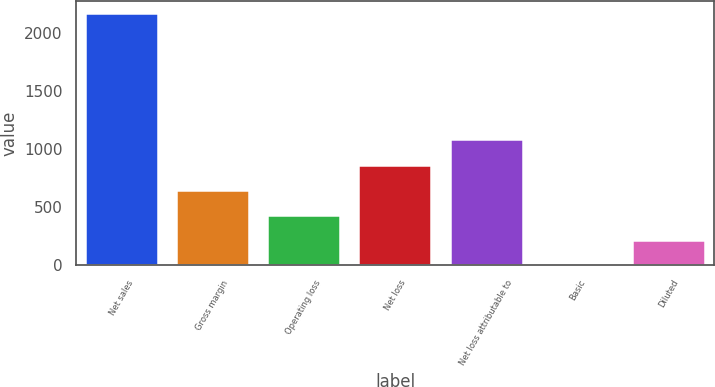Convert chart to OTSL. <chart><loc_0><loc_0><loc_500><loc_500><bar_chart><fcel>Net sales<fcel>Gross margin<fcel>Operating loss<fcel>Net loss<fcel>Net loss attributable to<fcel>Basic<fcel>Diluted<nl><fcel>2172<fcel>651.83<fcel>434.66<fcel>869<fcel>1086.17<fcel>0.32<fcel>217.49<nl></chart> 